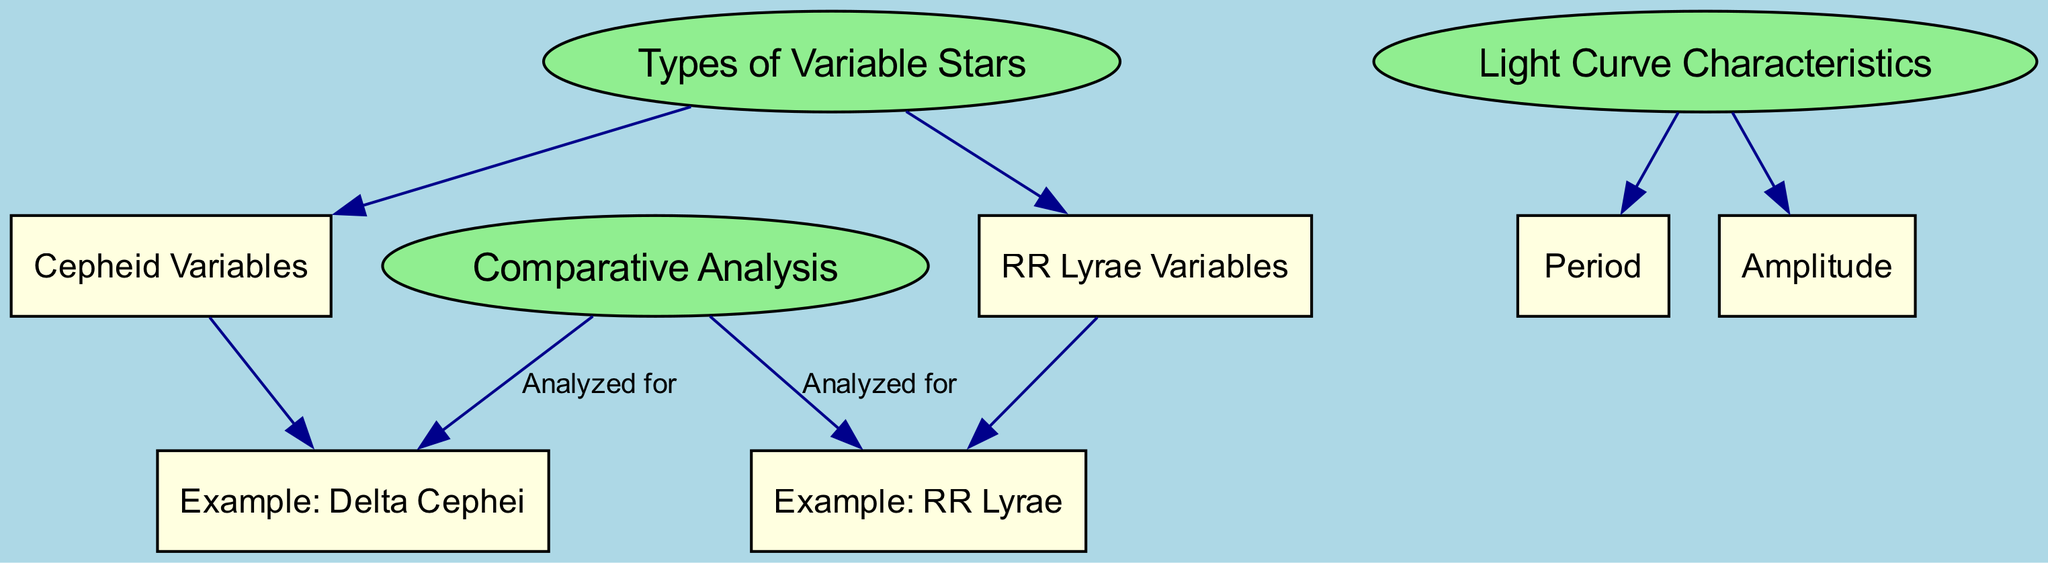What types of variable stars are represented? The diagram shows the nodes labeled "Cepheid Variables" and "RR Lyrae Variables" under the main category "Types of Variable Stars." These are the two types of variable stars mentioned in the diagram.
Answer: Cepheid Variables and RR Lyrae Variables What are the two light curve characteristics listed? The diagram includes the nodes "Period" and "Amplitude," which are attributes associated with light curves. These are the characteristics highlighted in the section "Light Curve Characteristics."
Answer: Period and Amplitude How many examples of variable stars are analyzed for comparison? In the diagram, "Delta Cephei" and "RR Lyrae" are pointed out as examples analyzed under the "Comparative Analysis" section. Thus, there are two examples shown in the diagram.
Answer: 2 What is the shape of the node representing "Types of Variable Stars"? The diagram identifies the node for "Types of Variable Stars" as an ellipse, which is a distinguishing feature as it sets it apart from rectangular nodes for other categories.
Answer: Ellipse Which example is specifically associated with cepheid variables? Referring to the nodes in the diagram, "Delta Cephei" is explicitly linked to "Cepheid Variables," indicating that it is an example of this type of variable star.
Answer: Delta Cephei What connects light curve characteristics with the examples? The diagram shows edges connecting "Period" and "Amplitude" to the central category "Light Curve Characteristics." However, the edges to the examples "Delta Cephei" and "RR Lyrae" indicate they are analyzed in the context of these characteristics under the "Comparative Analysis."
Answer: Light Curve Characteristics What node is analyzed for RR Lyrae example? The diagram explicitly links "RR Lyrae" under the "Comparative Analysis" category through an edge labeled "Analyzed for," indicating it's an example being considered in the context of the analysis.
Answer: RR Lyrae How many edges are connected to the types of variable stars? The "Types of Variable Stars" node connects to two other nodes: "Cepheid Variables" and "RR Lyrae Variables," thus having a total of two edges connected.
Answer: 2 